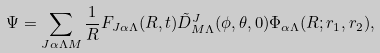<formula> <loc_0><loc_0><loc_500><loc_500>\Psi = \sum _ { J \alpha \Lambda M } \frac { 1 } { R } F _ { J \alpha \Lambda } ( R , t ) \tilde { D } ^ { J } _ { M \Lambda } ( \phi , \theta , 0 ) \Phi _ { \alpha \Lambda } ( R ; { r } _ { 1 } , { r } _ { 2 } ) ,</formula> 